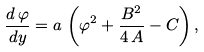Convert formula to latex. <formula><loc_0><loc_0><loc_500><loc_500>\frac { d \, \varphi } { d y } = a \, \left ( \varphi ^ { 2 } + \frac { B ^ { 2 } } { 4 \, A } - C \right ) ,</formula> 